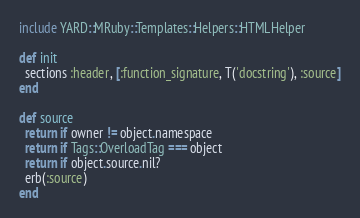<code> <loc_0><loc_0><loc_500><loc_500><_Ruby_>include YARD::MRuby::Templates::Helpers::HTMLHelper

def init
  sections :header, [:function_signature, T('docstring'), :source]
end

def source
  return if owner != object.namespace
  return if Tags::OverloadTag === object
  return if object.source.nil?
  erb(:source)
end
</code> 